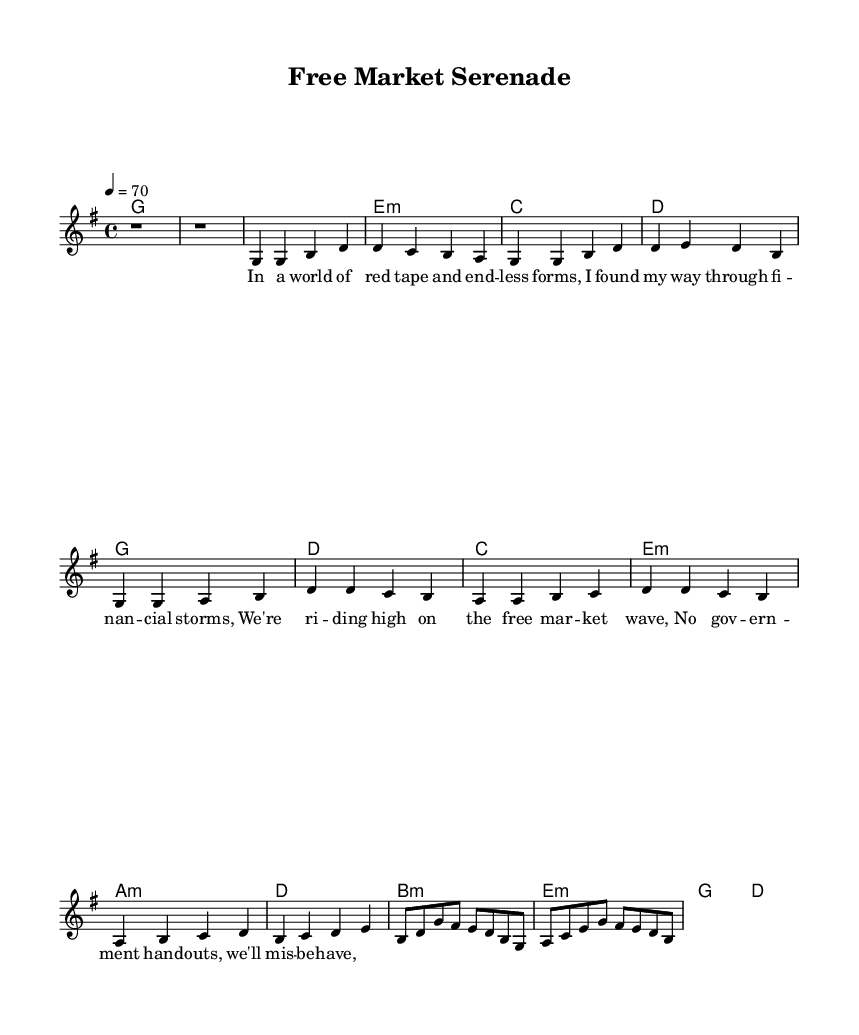What is the key signature of this music? The key signature is G major, which has one sharp (F#). You can identify the key signature by looking at the beginning of the staff, where the sharp is placed.
Answer: G major What is the time signature of this piece? The time signature is 4/4, which indicates there are four beats in each measure and a quarter note receives one beat. This is typically found near the beginning of the staff, indicated clearly.
Answer: 4/4 What is the tempo marking for the piece? The tempo marking is "4 = 70," meaning there should be 70 beats per minute, indicated between the title and the beginning of the music.
Answer: 70 How many measures are in the verse section? The verse section consists of four measures, counting each measure from the notation provided under the verse lyrics. Each musical line is separated by a vertical bar, indicating a measure.
Answer: 4 What chord follows the C chord in the chorus? The chord that follows the C chord is E minor, which is indicated in the chord changes below the melody line throughout the chorus.
Answer: E minor What style of music does this piece represent? This piece represents Classic Rock, which is characterized by its structured form, melodic elements, and anthemic choruses that focus on themes like financial success and personal freedom. The content in the lyrics and the overall sound align with Rock principles.
Answer: Classic Rock 